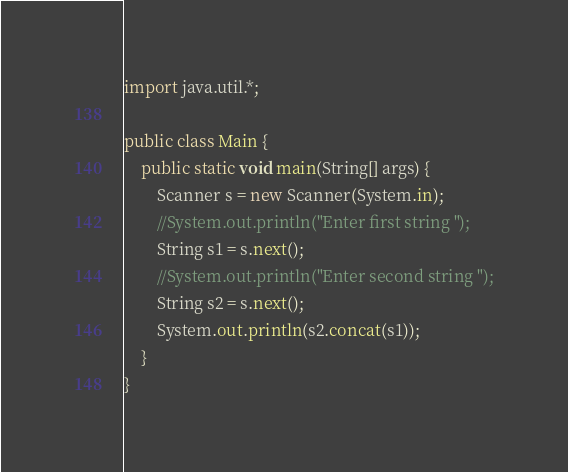<code> <loc_0><loc_0><loc_500><loc_500><_Java_>import java.util.*;

public class Main {
    public static void main(String[] args) {
        Scanner s = new Scanner(System.in);
        //System.out.println("Enter first string ");
        String s1 = s.next();
        //System.out.println("Enter second string ");
        String s2 = s.next();
        System.out.println(s2.concat(s1));
    }
}</code> 